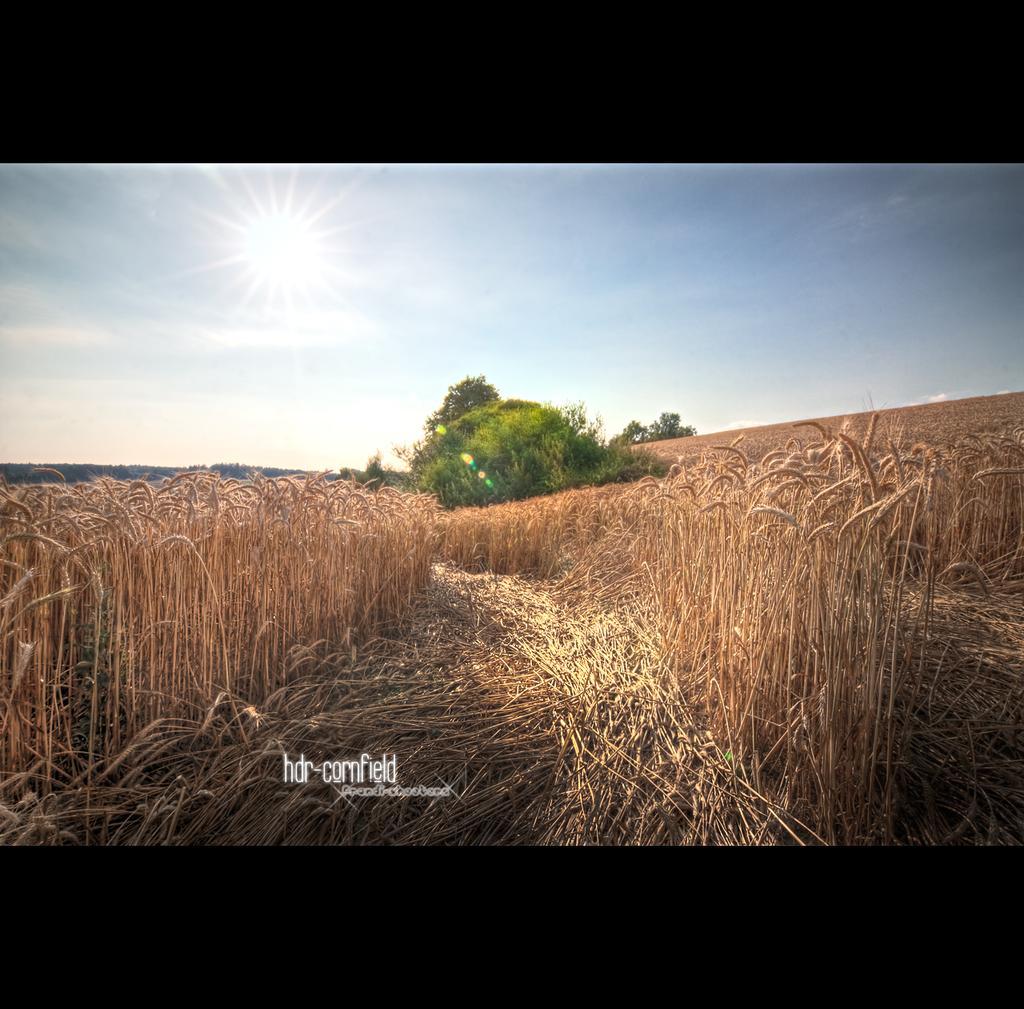In one or two sentences, can you explain what this image depicts? In the center of the image, we can see fields and in the background, there are trees. At the bottom, there is some text written and at the top, there is sun in the sky. 